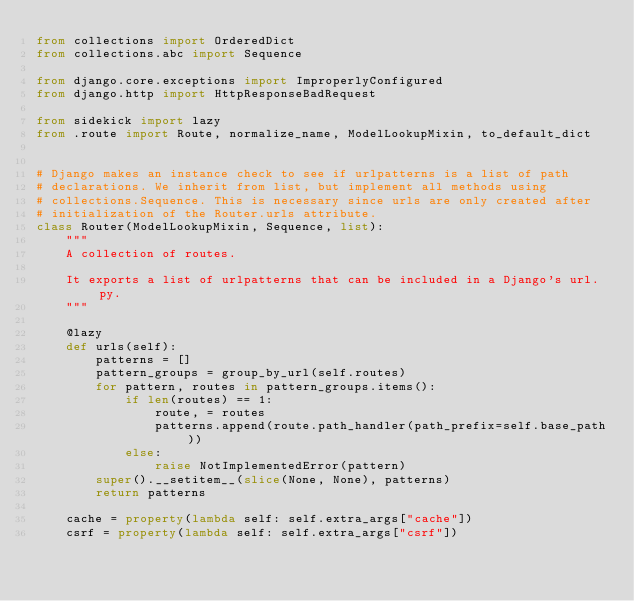<code> <loc_0><loc_0><loc_500><loc_500><_Python_>from collections import OrderedDict
from collections.abc import Sequence

from django.core.exceptions import ImproperlyConfigured
from django.http import HttpResponseBadRequest

from sidekick import lazy
from .route import Route, normalize_name, ModelLookupMixin, to_default_dict


# Django makes an instance check to see if urlpatterns is a list of path
# declarations. We inherit from list, but implement all methods using
# collections.Sequence. This is necessary since urls are only created after
# initialization of the Router.urls attribute.
class Router(ModelLookupMixin, Sequence, list):
    """
    A collection of routes.

    It exports a list of urlpatterns that can be included in a Django's url.py.
    """

    @lazy
    def urls(self):
        patterns = []
        pattern_groups = group_by_url(self.routes)
        for pattern, routes in pattern_groups.items():
            if len(routes) == 1:
                route, = routes
                patterns.append(route.path_handler(path_prefix=self.base_path))
            else:
                raise NotImplementedError(pattern)
        super().__setitem__(slice(None, None), patterns)
        return patterns

    cache = property(lambda self: self.extra_args["cache"])
    csrf = property(lambda self: self.extra_args["csrf"])</code> 